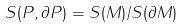Convert formula to latex. <formula><loc_0><loc_0><loc_500><loc_500>S ( P , \partial P ) = S ( M ) / S ( \partial M )</formula> 